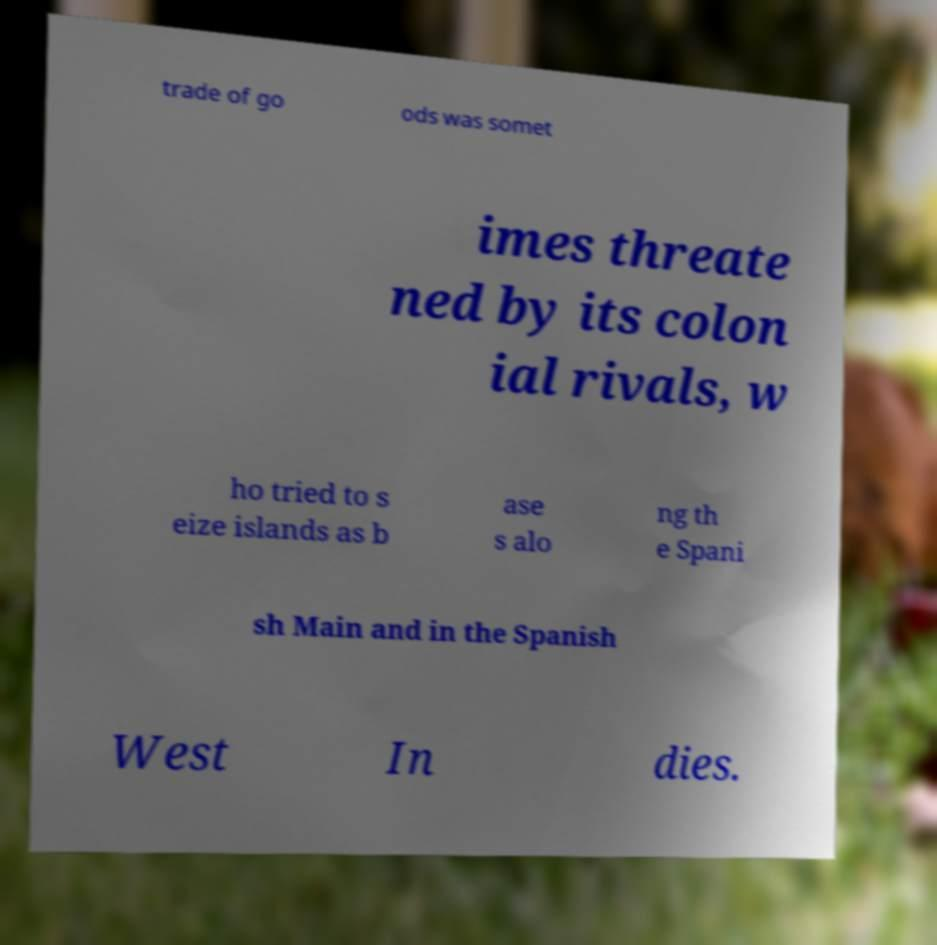What messages or text are displayed in this image? I need them in a readable, typed format. trade of go ods was somet imes threate ned by its colon ial rivals, w ho tried to s eize islands as b ase s alo ng th e Spani sh Main and in the Spanish West In dies. 